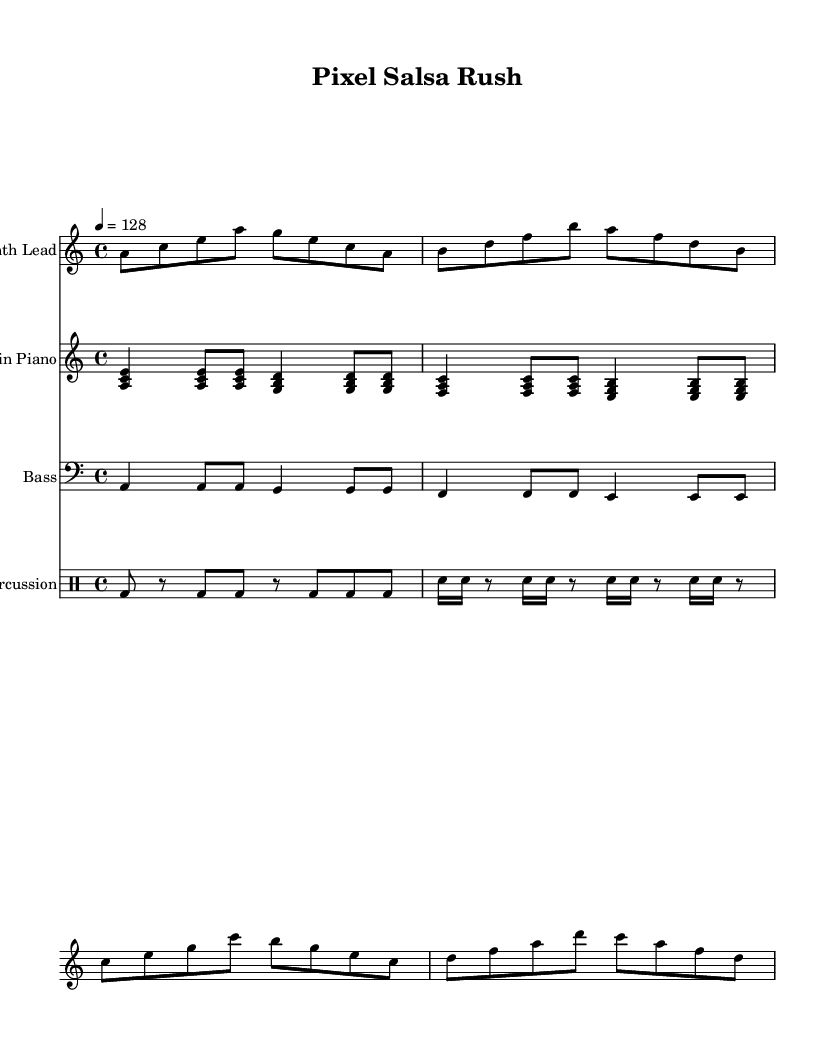What is the key signature of this music? The key signature is A minor, which has no sharps or flats. This is identified from the global settings at the beginning of the sheet music.
Answer: A minor What is the time signature of this music? The time signature is 4/4, as indicated in the global settings section. This means there are four beats per measure, and the quarter note gets one beat.
Answer: 4/4 What is the tempo marking for this piece? The tempo marking is 128 beats per minute, indicated at the beginning of the global settings. This means the piece should be played at a speed of 128 beats per minute.
Answer: 128 How many bars are there in the synth lead section? The synth lead section has 8 bars, which can be counted by observing the measures in the music notation provided for the synth lead. Each line typically represents a set of four bars in common time signatures.
Answer: 8 What type of instruments are used in this piece? The instruments include Synth Lead, Latin Piano, Bass, and Percussion. This is determined from the score section, where each instrument is explicitly named.
Answer: Synth Lead, Latin Piano, Bass, Percussion What rhythmic pattern is mainly used in the percussion section? The percussion section predominantly features a combination of bass drum and snare hits, with alternating rhythms of eighth and sixteenth notes. This can be analyzed through the drumming notation provided in the percussion part.
Answer: Bass and snare What is the primary chord used in the Latin piano section? The primary chord in the Latin piano section is A minor, which can be derived from the first chord shown in the treble staff of the piano part.
Answer: A minor 